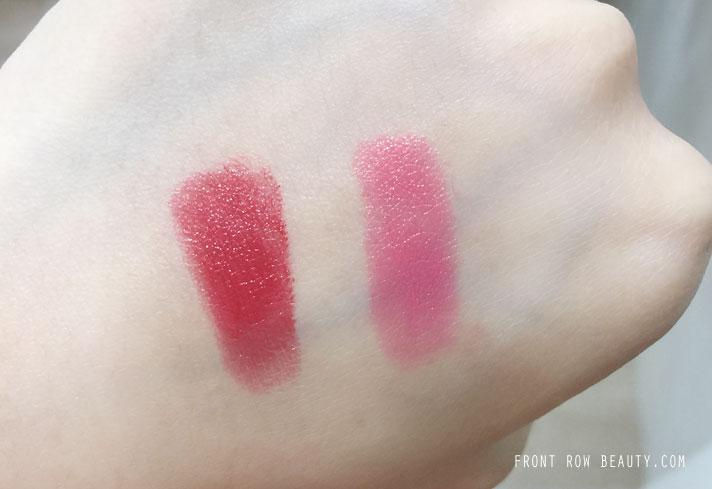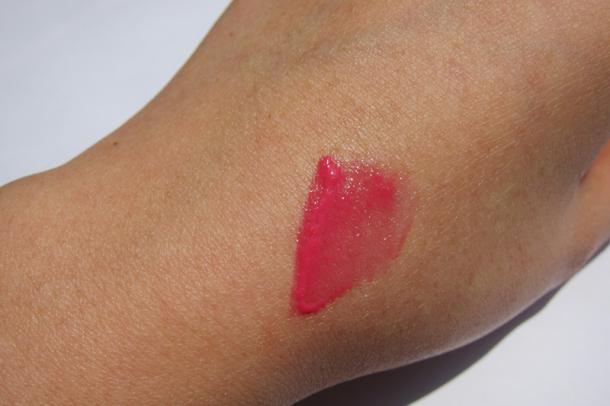The first image is the image on the left, the second image is the image on the right. Considering the images on both sides, is "An image shows exactly two lipstick smears on a closed fist with pale skin." valid? Answer yes or no. Yes. The first image is the image on the left, the second image is the image on the right. Given the left and right images, does the statement "There are two lipstick stripes on the skin in one of the images." hold true? Answer yes or no. Yes. 